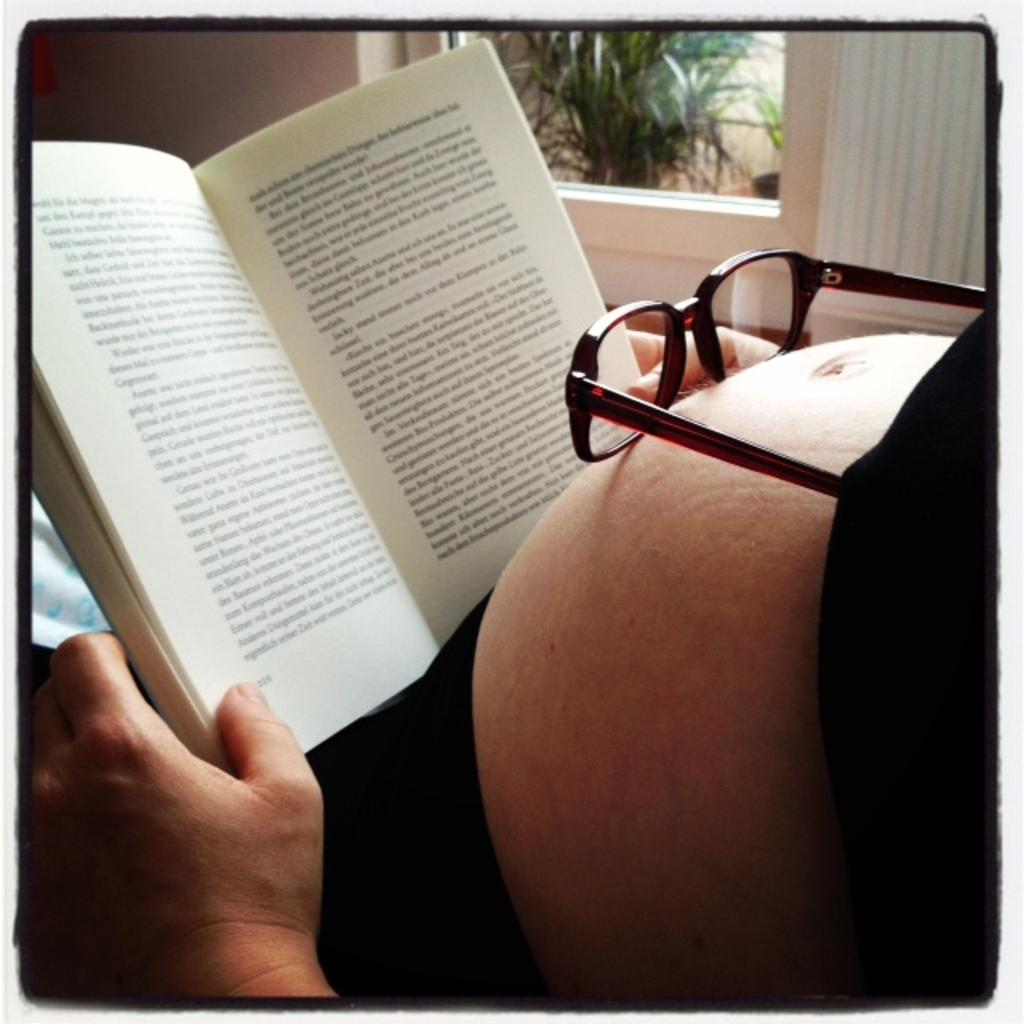What object related to reading can be seen in the image? There is a book in the image. What accessory related to vision can be seen in the image? There are spectacles in the image. What type of living organism can be seen in the image? There is a plant in the image. What type of window treatment is present in the image? There is a curtain in the image. What type of architectural feature is present in the image? There are walls in the image. Whose body part is visible in the image? A human hand and a human belly are visible in the image. What type of boot is visible in the image? There is no boot present in the image. What type of animal can be seen interacting with the book in the image? There is no animal present in the image. 